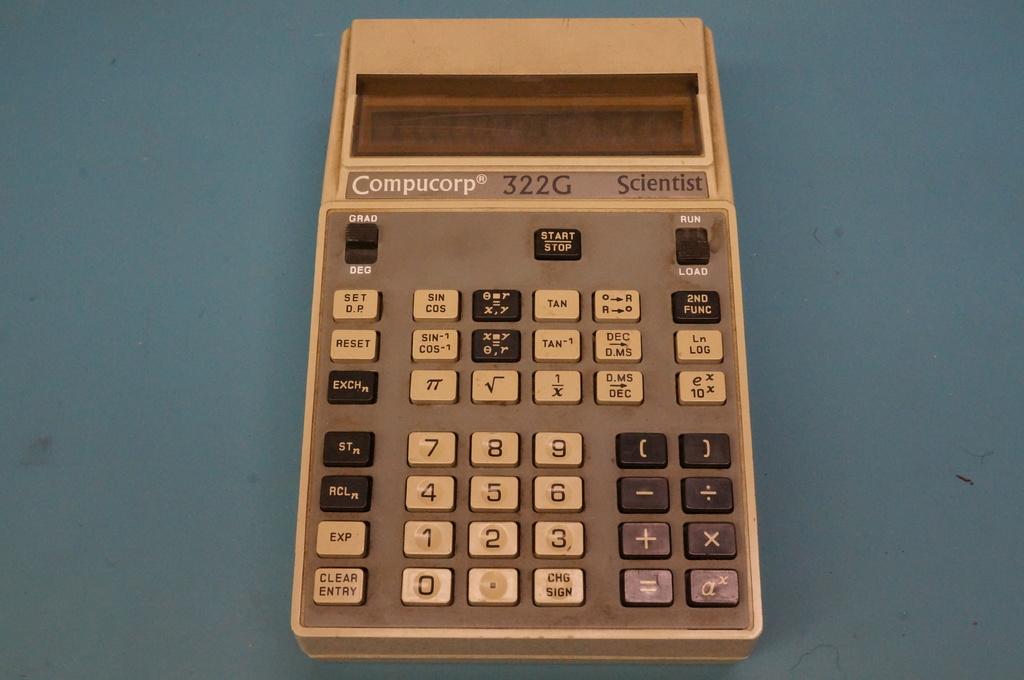What is the label for the button on the bottom left?
Offer a very short reply. Clear entry. 